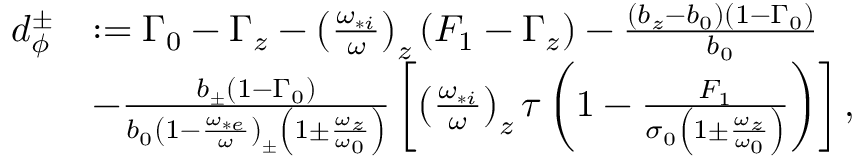Convert formula to latex. <formula><loc_0><loc_0><loc_500><loc_500>\begin{array} { r l } { d _ { \phi } ^ { \pm } } & { \colon = \Gamma _ { 0 } - \Gamma _ { z } - \left ( \frac { \omega _ { * i } } { \omega } \right ) _ { z } \left ( F _ { 1 } - \Gamma _ { z } \right ) - \frac { \left ( b _ { z } - b _ { 0 } \right ) \left ( 1 - \Gamma _ { 0 } \right ) } { b _ { 0 } } } \\ & { - \frac { b _ { \pm } \left ( 1 - \Gamma _ { 0 } \right ) } { b _ { 0 } \left ( 1 - \frac { \omega _ { * e } } { \omega } \right ) _ { \pm } \left ( 1 \pm \frac { \omega _ { z } } { \omega _ { 0 } } \right ) } \left [ \left ( \frac { \omega _ { * i } } { \omega } \right ) _ { z } \tau \left ( 1 - \frac { F _ { 1 } } { \sigma _ { 0 } \left ( 1 \pm \frac { \omega _ { z } } { \omega _ { 0 } } \right ) } \right ) \right ] , } \end{array}</formula> 